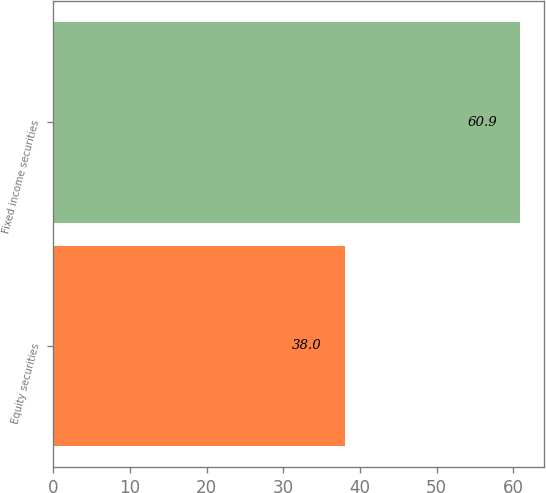<chart> <loc_0><loc_0><loc_500><loc_500><bar_chart><fcel>Equity securities<fcel>Fixed income securities<nl><fcel>38<fcel>60.9<nl></chart> 